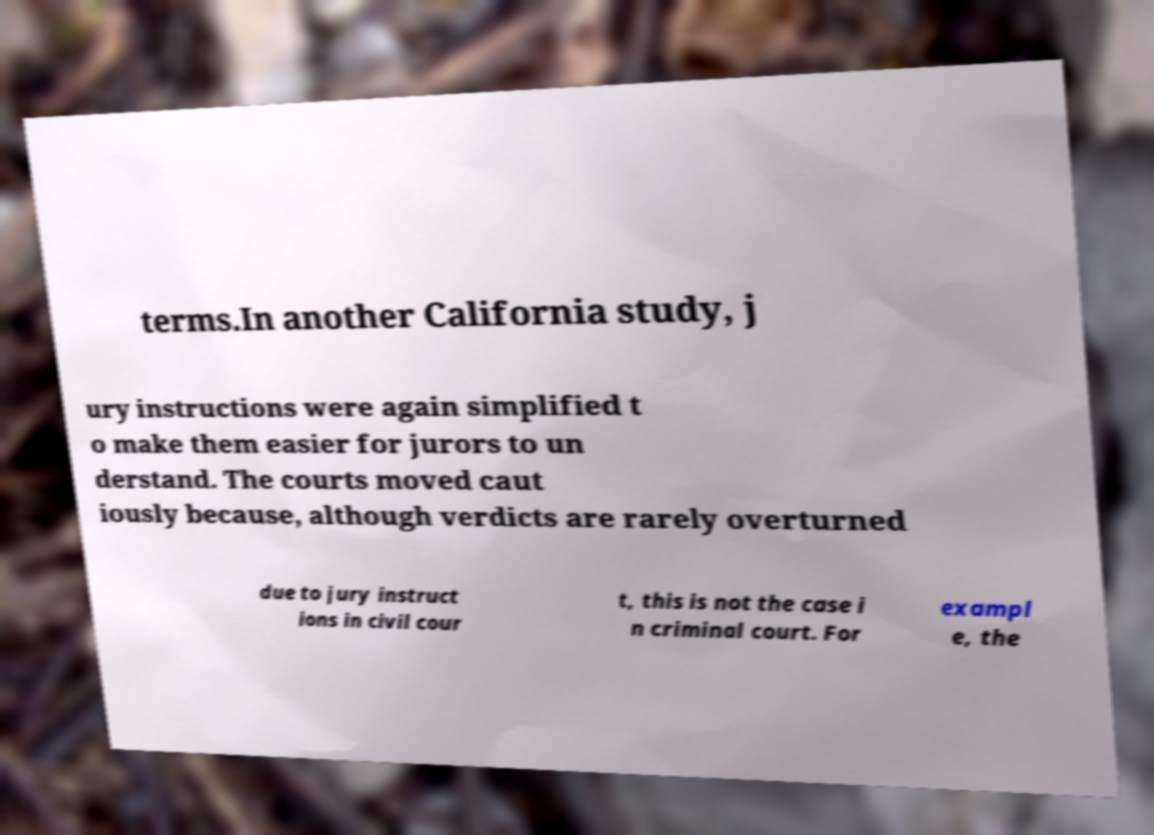Please read and relay the text visible in this image. What does it say? terms.In another California study, j ury instructions were again simplified t o make them easier for jurors to un derstand. The courts moved caut iously because, although verdicts are rarely overturned due to jury instruct ions in civil cour t, this is not the case i n criminal court. For exampl e, the 